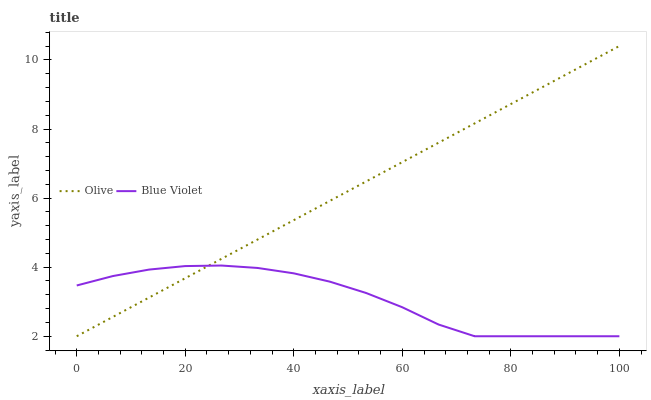Does Blue Violet have the maximum area under the curve?
Answer yes or no. No. Is Blue Violet the smoothest?
Answer yes or no. No. Does Blue Violet have the highest value?
Answer yes or no. No. 